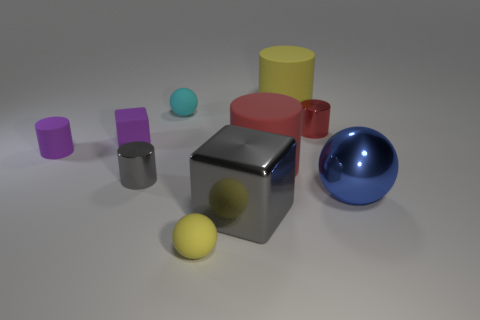What number of tiny objects are either gray things or purple objects?
Your answer should be very brief. 3. Does the tiny purple cylinder have the same material as the blue ball?
Keep it short and to the point. No. There is a tiny cylinder that is on the left side of the rubber cube; how many big metallic things are right of it?
Keep it short and to the point. 2. Is there a tiny purple thing of the same shape as the blue metal thing?
Provide a succinct answer. No. There is a red thing behind the big red rubber thing; is it the same shape as the large yellow matte object right of the purple cylinder?
Provide a succinct answer. Yes. There is a thing that is in front of the large blue sphere and behind the small yellow ball; what is its shape?
Your answer should be very brief. Cube. Are there any yellow objects that have the same size as the gray block?
Keep it short and to the point. Yes. There is a metallic ball; is its color the same as the tiny sphere that is in front of the blue ball?
Offer a very short reply. No. What material is the yellow ball?
Your answer should be compact. Rubber. What is the color of the big rubber cylinder that is in front of the purple rubber cube?
Your response must be concise. Red. 